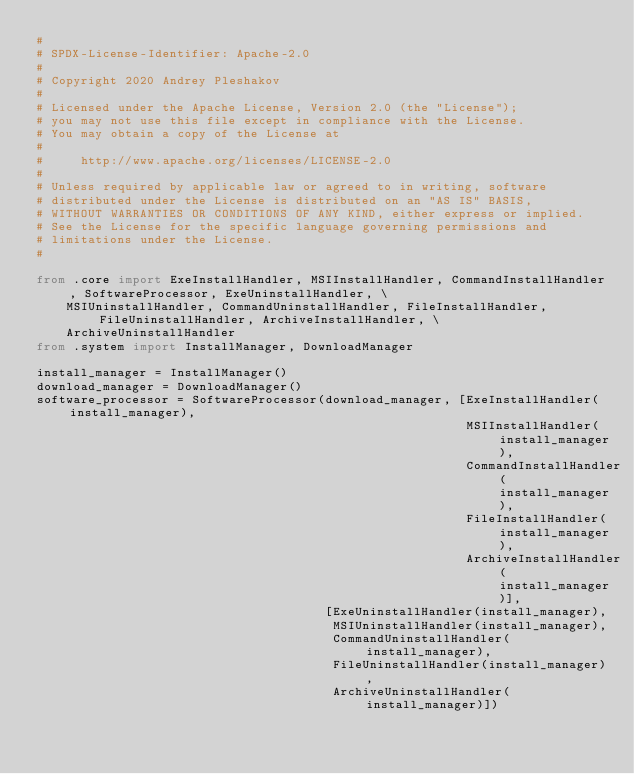<code> <loc_0><loc_0><loc_500><loc_500><_Python_>#
# SPDX-License-Identifier: Apache-2.0
#
# Copyright 2020 Andrey Pleshakov
#
# Licensed under the Apache License, Version 2.0 (the "License");
# you may not use this file except in compliance with the License.
# You may obtain a copy of the License at
#
#     http://www.apache.org/licenses/LICENSE-2.0
#
# Unless required by applicable law or agreed to in writing, software
# distributed under the License is distributed on an "AS IS" BASIS,
# WITHOUT WARRANTIES OR CONDITIONS OF ANY KIND, either express or implied.
# See the License for the specific language governing permissions and
# limitations under the License.
#

from .core import ExeInstallHandler, MSIInstallHandler, CommandInstallHandler, SoftwareProcessor, ExeUninstallHandler, \
    MSIUninstallHandler, CommandUninstallHandler, FileInstallHandler, FileUninstallHandler, ArchiveInstallHandler, \
    ArchiveUninstallHandler
from .system import InstallManager, DownloadManager

install_manager = InstallManager()
download_manager = DownloadManager()
software_processor = SoftwareProcessor(download_manager, [ExeInstallHandler(install_manager),
                                                          MSIInstallHandler(install_manager),
                                                          CommandInstallHandler(install_manager),
                                                          FileInstallHandler(install_manager),
                                                          ArchiveInstallHandler(install_manager)],
                                       [ExeUninstallHandler(install_manager),
                                        MSIUninstallHandler(install_manager),
                                        CommandUninstallHandler(install_manager),
                                        FileUninstallHandler(install_manager),
                                        ArchiveUninstallHandler(install_manager)])
</code> 